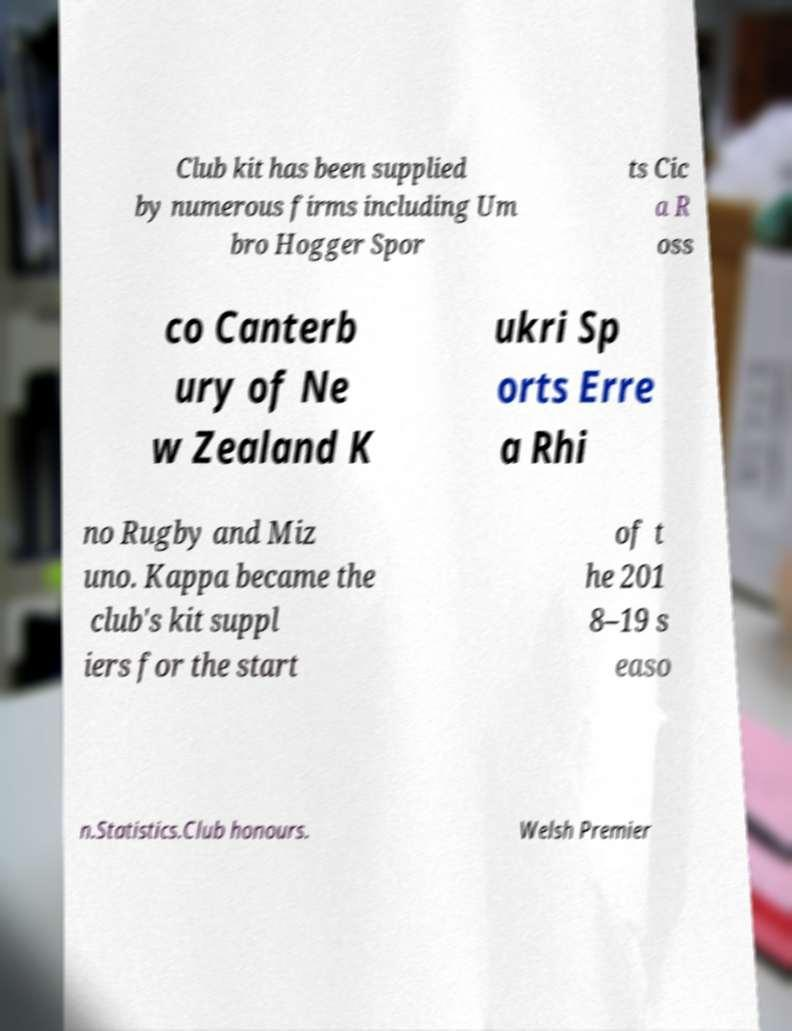Please identify and transcribe the text found in this image. Club kit has been supplied by numerous firms including Um bro Hogger Spor ts Cic a R oss co Canterb ury of Ne w Zealand K ukri Sp orts Erre a Rhi no Rugby and Miz uno. Kappa became the club's kit suppl iers for the start of t he 201 8–19 s easo n.Statistics.Club honours. Welsh Premier 